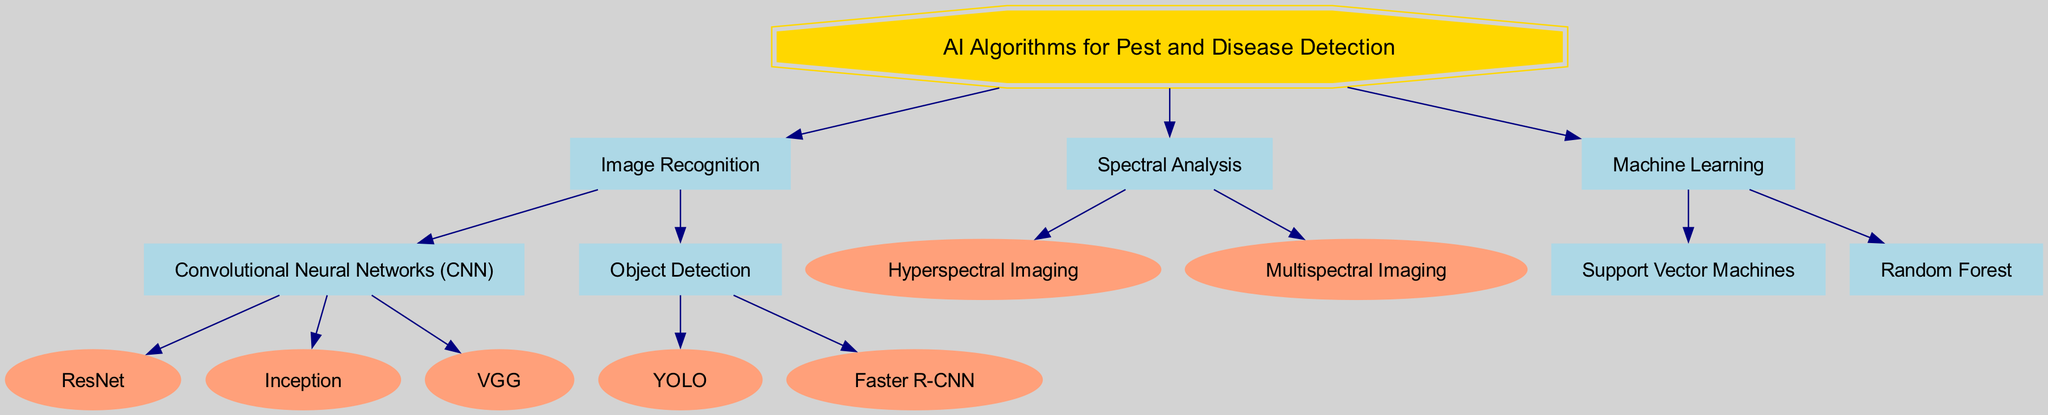What are the three main categories of AI algorithms for pest and disease detection? The diagram shows three main categories listed under "AI Algorithms for Pest and Disease Detection": Image Recognition, Spectral Analysis, and Machine Learning.
Answer: Image Recognition, Spectral Analysis, Machine Learning How many types of algorithms are under Image Recognition? Under the Image Recognition category, there are two types of algorithms: Convolutional Neural Networks and Object Detection.
Answer: 2 Which machine learning technique is mentioned in the diagram? The diagram lists two specific machine learning techniques: Support Vector Machines and Random Forest under the "Machine Learning" branch.
Answer: Support Vector Machines, Random Forest What is the relationship between Convolutional Neural Networks and Image Recognition? Convolutional Neural Networks (CNN) is a specific category listed under the broader category Image Recognition, indicating that CNN is a form or subcategory of image recognition techniques used in pest and disease detection.
Answer: Convolutional Neural Networks is part of Image Recognition Name one algorithm under the Object Detection branch. The Object Detection branch includes algorithms such as YOLO and Faster R-CNN. Asking for any one will yield either of those names.
Answer: YOLO (or Faster R-CNN) How many algorithms fall under Spectral Analysis? The Spectral Analysis category includes two algorithms: Hyperspectral Imaging and Multispectral Imaging, thus constituting a total of two algorithms.
Answer: 2 Which Image Recognition technique is associated with ResNet? ResNet is a specific algorithm listed under the Convolutional Neural Networks branch, which indicates it is a method used for image recognition within pest and disease detection.
Answer: Convolutional Neural Networks Which detection method has fewer algorithms, Convolutional Neural Networks or Spectral Analysis? Convolutional Neural Networks has three algorithms (ResNet, Inception, VGG), while Spectral Analysis has two (Hyperspectral Imaging, Multispectral Imaging). Therefore, Spectral Analysis has fewer algorithms.
Answer: Spectral Analysis What are the two branches of the Image Recognition category? The Image Recognition category has two main branches: Convolutional Neural Networks and Object Detection, indicating that these are the primary paths of this type of algorithm.
Answer: Convolutional Neural Networks, Object Detection 